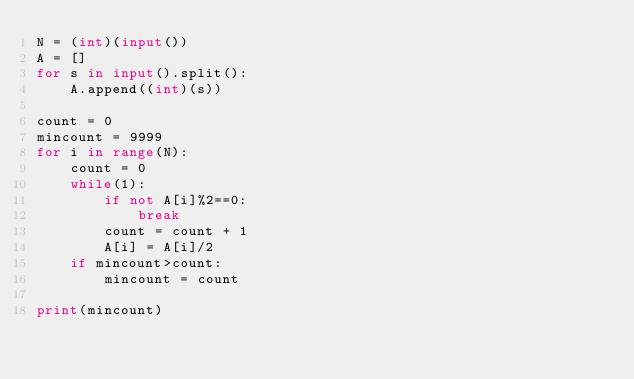<code> <loc_0><loc_0><loc_500><loc_500><_Python_>N = (int)(input())
A = []
for s in input().split():
    A.append((int)(s))

count = 0
mincount = 9999
for i in range(N):
    count = 0
    while(1):
        if not A[i]%2==0:
            break
        count = count + 1
        A[i] = A[i]/2
    if mincount>count:
        mincount = count
        
print(mincount)</code> 